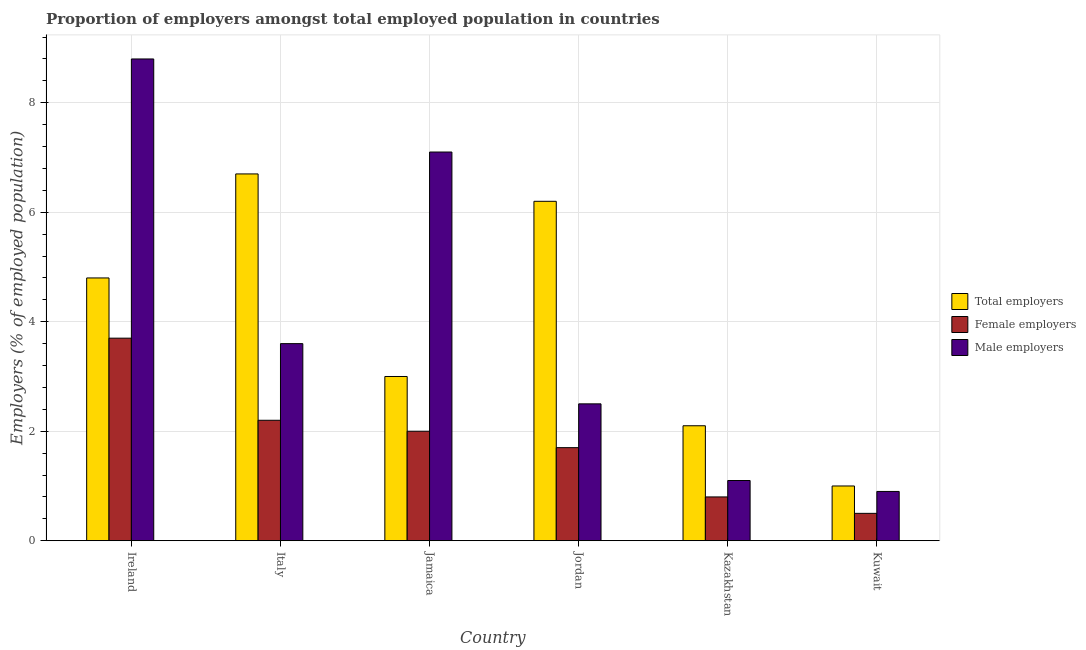Are the number of bars per tick equal to the number of legend labels?
Provide a short and direct response. Yes. What is the label of the 6th group of bars from the left?
Your answer should be very brief. Kuwait. In how many cases, is the number of bars for a given country not equal to the number of legend labels?
Ensure brevity in your answer.  0. What is the percentage of male employers in Kazakhstan?
Your response must be concise. 1.1. Across all countries, what is the maximum percentage of male employers?
Your answer should be compact. 8.8. Across all countries, what is the minimum percentage of male employers?
Provide a succinct answer. 0.9. In which country was the percentage of female employers minimum?
Offer a very short reply. Kuwait. What is the total percentage of male employers in the graph?
Ensure brevity in your answer.  24. What is the difference between the percentage of male employers in Ireland and that in Kazakhstan?
Give a very brief answer. 7.7. What is the difference between the percentage of male employers in Kazakhstan and the percentage of female employers in Jamaica?
Offer a very short reply. -0.9. What is the average percentage of male employers per country?
Offer a terse response. 4. What is the difference between the percentage of male employers and percentage of total employers in Ireland?
Offer a terse response. 4. In how many countries, is the percentage of female employers greater than 6.8 %?
Keep it short and to the point. 0. What is the ratio of the percentage of female employers in Jordan to that in Kuwait?
Provide a short and direct response. 3.4. What is the difference between the highest and the second highest percentage of male employers?
Provide a succinct answer. 1.7. What is the difference between the highest and the lowest percentage of male employers?
Your answer should be very brief. 7.9. What does the 3rd bar from the left in Kuwait represents?
Provide a short and direct response. Male employers. What does the 3rd bar from the right in Kazakhstan represents?
Offer a terse response. Total employers. Is it the case that in every country, the sum of the percentage of total employers and percentage of female employers is greater than the percentage of male employers?
Provide a succinct answer. No. Are all the bars in the graph horizontal?
Your answer should be compact. No. How many countries are there in the graph?
Offer a very short reply. 6. What is the difference between two consecutive major ticks on the Y-axis?
Keep it short and to the point. 2. How many legend labels are there?
Offer a terse response. 3. What is the title of the graph?
Offer a very short reply. Proportion of employers amongst total employed population in countries. Does "Profit Tax" appear as one of the legend labels in the graph?
Provide a succinct answer. No. What is the label or title of the Y-axis?
Provide a short and direct response. Employers (% of employed population). What is the Employers (% of employed population) in Total employers in Ireland?
Your answer should be compact. 4.8. What is the Employers (% of employed population) of Female employers in Ireland?
Ensure brevity in your answer.  3.7. What is the Employers (% of employed population) in Male employers in Ireland?
Provide a short and direct response. 8.8. What is the Employers (% of employed population) in Total employers in Italy?
Offer a very short reply. 6.7. What is the Employers (% of employed population) in Female employers in Italy?
Provide a short and direct response. 2.2. What is the Employers (% of employed population) in Male employers in Italy?
Your response must be concise. 3.6. What is the Employers (% of employed population) of Total employers in Jamaica?
Ensure brevity in your answer.  3. What is the Employers (% of employed population) of Female employers in Jamaica?
Provide a succinct answer. 2. What is the Employers (% of employed population) in Male employers in Jamaica?
Your answer should be very brief. 7.1. What is the Employers (% of employed population) of Total employers in Jordan?
Your answer should be very brief. 6.2. What is the Employers (% of employed population) of Female employers in Jordan?
Make the answer very short. 1.7. What is the Employers (% of employed population) of Total employers in Kazakhstan?
Your response must be concise. 2.1. What is the Employers (% of employed population) of Female employers in Kazakhstan?
Your answer should be very brief. 0.8. What is the Employers (% of employed population) in Male employers in Kazakhstan?
Offer a terse response. 1.1. What is the Employers (% of employed population) of Total employers in Kuwait?
Give a very brief answer. 1. What is the Employers (% of employed population) in Female employers in Kuwait?
Offer a very short reply. 0.5. What is the Employers (% of employed population) of Male employers in Kuwait?
Keep it short and to the point. 0.9. Across all countries, what is the maximum Employers (% of employed population) of Total employers?
Keep it short and to the point. 6.7. Across all countries, what is the maximum Employers (% of employed population) of Female employers?
Make the answer very short. 3.7. Across all countries, what is the maximum Employers (% of employed population) of Male employers?
Give a very brief answer. 8.8. Across all countries, what is the minimum Employers (% of employed population) of Female employers?
Make the answer very short. 0.5. Across all countries, what is the minimum Employers (% of employed population) of Male employers?
Keep it short and to the point. 0.9. What is the total Employers (% of employed population) of Total employers in the graph?
Your answer should be compact. 23.8. What is the total Employers (% of employed population) of Male employers in the graph?
Keep it short and to the point. 24. What is the difference between the Employers (% of employed population) in Male employers in Ireland and that in Italy?
Offer a very short reply. 5.2. What is the difference between the Employers (% of employed population) of Total employers in Ireland and that in Jamaica?
Keep it short and to the point. 1.8. What is the difference between the Employers (% of employed population) of Male employers in Ireland and that in Jordan?
Ensure brevity in your answer.  6.3. What is the difference between the Employers (% of employed population) of Total employers in Ireland and that in Kazakhstan?
Provide a succinct answer. 2.7. What is the difference between the Employers (% of employed population) in Female employers in Ireland and that in Kazakhstan?
Give a very brief answer. 2.9. What is the difference between the Employers (% of employed population) in Total employers in Ireland and that in Kuwait?
Keep it short and to the point. 3.8. What is the difference between the Employers (% of employed population) of Total employers in Italy and that in Jamaica?
Ensure brevity in your answer.  3.7. What is the difference between the Employers (% of employed population) in Male employers in Italy and that in Jamaica?
Offer a very short reply. -3.5. What is the difference between the Employers (% of employed population) in Total employers in Italy and that in Jordan?
Your answer should be very brief. 0.5. What is the difference between the Employers (% of employed population) in Male employers in Italy and that in Jordan?
Your answer should be compact. 1.1. What is the difference between the Employers (% of employed population) of Total employers in Italy and that in Kazakhstan?
Make the answer very short. 4.6. What is the difference between the Employers (% of employed population) of Female employers in Italy and that in Kazakhstan?
Offer a terse response. 1.4. What is the difference between the Employers (% of employed population) of Female employers in Italy and that in Kuwait?
Offer a very short reply. 1.7. What is the difference between the Employers (% of employed population) in Total employers in Jamaica and that in Kazakhstan?
Give a very brief answer. 0.9. What is the difference between the Employers (% of employed population) in Female employers in Jamaica and that in Kazakhstan?
Ensure brevity in your answer.  1.2. What is the difference between the Employers (% of employed population) in Total employers in Jamaica and that in Kuwait?
Give a very brief answer. 2. What is the difference between the Employers (% of employed population) of Female employers in Jamaica and that in Kuwait?
Provide a short and direct response. 1.5. What is the difference between the Employers (% of employed population) in Male employers in Jamaica and that in Kuwait?
Provide a succinct answer. 6.2. What is the difference between the Employers (% of employed population) of Total employers in Jordan and that in Kazakhstan?
Make the answer very short. 4.1. What is the difference between the Employers (% of employed population) of Female employers in Jordan and that in Kazakhstan?
Offer a terse response. 0.9. What is the difference between the Employers (% of employed population) of Male employers in Jordan and that in Kazakhstan?
Make the answer very short. 1.4. What is the difference between the Employers (% of employed population) of Total employers in Jordan and that in Kuwait?
Offer a terse response. 5.2. What is the difference between the Employers (% of employed population) in Total employers in Kazakhstan and that in Kuwait?
Ensure brevity in your answer.  1.1. What is the difference between the Employers (% of employed population) in Female employers in Kazakhstan and that in Kuwait?
Make the answer very short. 0.3. What is the difference between the Employers (% of employed population) of Male employers in Kazakhstan and that in Kuwait?
Offer a very short reply. 0.2. What is the difference between the Employers (% of employed population) in Total employers in Ireland and the Employers (% of employed population) in Female employers in Italy?
Your answer should be very brief. 2.6. What is the difference between the Employers (% of employed population) in Total employers in Ireland and the Employers (% of employed population) in Male employers in Jamaica?
Your answer should be compact. -2.3. What is the difference between the Employers (% of employed population) in Total employers in Ireland and the Employers (% of employed population) in Female employers in Kazakhstan?
Offer a terse response. 4. What is the difference between the Employers (% of employed population) of Total employers in Ireland and the Employers (% of employed population) of Male employers in Kazakhstan?
Provide a short and direct response. 3.7. What is the difference between the Employers (% of employed population) in Female employers in Ireland and the Employers (% of employed population) in Male employers in Kazakhstan?
Offer a terse response. 2.6. What is the difference between the Employers (% of employed population) in Total employers in Ireland and the Employers (% of employed population) in Female employers in Kuwait?
Your answer should be very brief. 4.3. What is the difference between the Employers (% of employed population) in Total employers in Ireland and the Employers (% of employed population) in Male employers in Kuwait?
Provide a succinct answer. 3.9. What is the difference between the Employers (% of employed population) of Female employers in Italy and the Employers (% of employed population) of Male employers in Jamaica?
Keep it short and to the point. -4.9. What is the difference between the Employers (% of employed population) of Total employers in Italy and the Employers (% of employed population) of Male employers in Jordan?
Offer a very short reply. 4.2. What is the difference between the Employers (% of employed population) of Female employers in Italy and the Employers (% of employed population) of Male employers in Kazakhstan?
Your response must be concise. 1.1. What is the difference between the Employers (% of employed population) in Total employers in Italy and the Employers (% of employed population) in Female employers in Kuwait?
Your answer should be compact. 6.2. What is the difference between the Employers (% of employed population) in Female employers in Italy and the Employers (% of employed population) in Male employers in Kuwait?
Offer a terse response. 1.3. What is the difference between the Employers (% of employed population) in Total employers in Jamaica and the Employers (% of employed population) in Female employers in Jordan?
Keep it short and to the point. 1.3. What is the difference between the Employers (% of employed population) of Total employers in Jamaica and the Employers (% of employed population) of Male employers in Jordan?
Ensure brevity in your answer.  0.5. What is the difference between the Employers (% of employed population) in Female employers in Jamaica and the Employers (% of employed population) in Male employers in Jordan?
Offer a terse response. -0.5. What is the difference between the Employers (% of employed population) of Total employers in Jamaica and the Employers (% of employed population) of Male employers in Kazakhstan?
Make the answer very short. 1.9. What is the difference between the Employers (% of employed population) in Total employers in Jamaica and the Employers (% of employed population) in Female employers in Kuwait?
Give a very brief answer. 2.5. What is the difference between the Employers (% of employed population) of Total employers in Jamaica and the Employers (% of employed population) of Male employers in Kuwait?
Provide a short and direct response. 2.1. What is the difference between the Employers (% of employed population) of Female employers in Jamaica and the Employers (% of employed population) of Male employers in Kuwait?
Make the answer very short. 1.1. What is the difference between the Employers (% of employed population) of Total employers in Jordan and the Employers (% of employed population) of Male employers in Kazakhstan?
Offer a very short reply. 5.1. What is the difference between the Employers (% of employed population) in Female employers in Jordan and the Employers (% of employed population) in Male employers in Kazakhstan?
Provide a short and direct response. 0.6. What is the difference between the Employers (% of employed population) of Total employers in Jordan and the Employers (% of employed population) of Female employers in Kuwait?
Make the answer very short. 5.7. What is the difference between the Employers (% of employed population) in Total employers in Jordan and the Employers (% of employed population) in Male employers in Kuwait?
Your answer should be very brief. 5.3. What is the difference between the Employers (% of employed population) in Female employers in Jordan and the Employers (% of employed population) in Male employers in Kuwait?
Provide a short and direct response. 0.8. What is the difference between the Employers (% of employed population) of Total employers in Kazakhstan and the Employers (% of employed population) of Female employers in Kuwait?
Your response must be concise. 1.6. What is the difference between the Employers (% of employed population) in Total employers in Kazakhstan and the Employers (% of employed population) in Male employers in Kuwait?
Give a very brief answer. 1.2. What is the difference between the Employers (% of employed population) of Female employers in Kazakhstan and the Employers (% of employed population) of Male employers in Kuwait?
Give a very brief answer. -0.1. What is the average Employers (% of employed population) of Total employers per country?
Your answer should be very brief. 3.97. What is the average Employers (% of employed population) in Female employers per country?
Give a very brief answer. 1.82. What is the difference between the Employers (% of employed population) of Total employers and Employers (% of employed population) of Male employers in Ireland?
Provide a succinct answer. -4. What is the difference between the Employers (% of employed population) in Female employers and Employers (% of employed population) in Male employers in Ireland?
Offer a very short reply. -5.1. What is the difference between the Employers (% of employed population) in Female employers and Employers (% of employed population) in Male employers in Italy?
Your answer should be compact. -1.4. What is the difference between the Employers (% of employed population) in Total employers and Employers (% of employed population) in Female employers in Jamaica?
Keep it short and to the point. 1. What is the difference between the Employers (% of employed population) of Female employers and Employers (% of employed population) of Male employers in Jamaica?
Provide a succinct answer. -5.1. What is the difference between the Employers (% of employed population) of Total employers and Employers (% of employed population) of Female employers in Kazakhstan?
Give a very brief answer. 1.3. What is the difference between the Employers (% of employed population) of Total employers and Employers (% of employed population) of Male employers in Kazakhstan?
Offer a terse response. 1. What is the ratio of the Employers (% of employed population) of Total employers in Ireland to that in Italy?
Your answer should be very brief. 0.72. What is the ratio of the Employers (% of employed population) in Female employers in Ireland to that in Italy?
Offer a very short reply. 1.68. What is the ratio of the Employers (% of employed population) in Male employers in Ireland to that in Italy?
Your answer should be very brief. 2.44. What is the ratio of the Employers (% of employed population) in Total employers in Ireland to that in Jamaica?
Offer a terse response. 1.6. What is the ratio of the Employers (% of employed population) in Female employers in Ireland to that in Jamaica?
Provide a succinct answer. 1.85. What is the ratio of the Employers (% of employed population) in Male employers in Ireland to that in Jamaica?
Your response must be concise. 1.24. What is the ratio of the Employers (% of employed population) in Total employers in Ireland to that in Jordan?
Provide a succinct answer. 0.77. What is the ratio of the Employers (% of employed population) of Female employers in Ireland to that in Jordan?
Ensure brevity in your answer.  2.18. What is the ratio of the Employers (% of employed population) in Male employers in Ireland to that in Jordan?
Your answer should be compact. 3.52. What is the ratio of the Employers (% of employed population) in Total employers in Ireland to that in Kazakhstan?
Give a very brief answer. 2.29. What is the ratio of the Employers (% of employed population) of Female employers in Ireland to that in Kazakhstan?
Make the answer very short. 4.62. What is the ratio of the Employers (% of employed population) of Male employers in Ireland to that in Kazakhstan?
Offer a terse response. 8. What is the ratio of the Employers (% of employed population) in Male employers in Ireland to that in Kuwait?
Your response must be concise. 9.78. What is the ratio of the Employers (% of employed population) of Total employers in Italy to that in Jamaica?
Provide a succinct answer. 2.23. What is the ratio of the Employers (% of employed population) of Female employers in Italy to that in Jamaica?
Your answer should be compact. 1.1. What is the ratio of the Employers (% of employed population) of Male employers in Italy to that in Jamaica?
Provide a short and direct response. 0.51. What is the ratio of the Employers (% of employed population) of Total employers in Italy to that in Jordan?
Offer a terse response. 1.08. What is the ratio of the Employers (% of employed population) of Female employers in Italy to that in Jordan?
Offer a very short reply. 1.29. What is the ratio of the Employers (% of employed population) in Male employers in Italy to that in Jordan?
Keep it short and to the point. 1.44. What is the ratio of the Employers (% of employed population) in Total employers in Italy to that in Kazakhstan?
Give a very brief answer. 3.19. What is the ratio of the Employers (% of employed population) of Female employers in Italy to that in Kazakhstan?
Offer a very short reply. 2.75. What is the ratio of the Employers (% of employed population) of Male employers in Italy to that in Kazakhstan?
Provide a short and direct response. 3.27. What is the ratio of the Employers (% of employed population) of Total employers in Jamaica to that in Jordan?
Make the answer very short. 0.48. What is the ratio of the Employers (% of employed population) in Female employers in Jamaica to that in Jordan?
Give a very brief answer. 1.18. What is the ratio of the Employers (% of employed population) in Male employers in Jamaica to that in Jordan?
Offer a very short reply. 2.84. What is the ratio of the Employers (% of employed population) in Total employers in Jamaica to that in Kazakhstan?
Your answer should be compact. 1.43. What is the ratio of the Employers (% of employed population) of Female employers in Jamaica to that in Kazakhstan?
Your answer should be compact. 2.5. What is the ratio of the Employers (% of employed population) of Male employers in Jamaica to that in Kazakhstan?
Offer a terse response. 6.45. What is the ratio of the Employers (% of employed population) in Male employers in Jamaica to that in Kuwait?
Your answer should be very brief. 7.89. What is the ratio of the Employers (% of employed population) in Total employers in Jordan to that in Kazakhstan?
Make the answer very short. 2.95. What is the ratio of the Employers (% of employed population) in Female employers in Jordan to that in Kazakhstan?
Your response must be concise. 2.12. What is the ratio of the Employers (% of employed population) of Male employers in Jordan to that in Kazakhstan?
Provide a succinct answer. 2.27. What is the ratio of the Employers (% of employed population) in Female employers in Jordan to that in Kuwait?
Provide a short and direct response. 3.4. What is the ratio of the Employers (% of employed population) of Male employers in Jordan to that in Kuwait?
Your answer should be very brief. 2.78. What is the ratio of the Employers (% of employed population) in Total employers in Kazakhstan to that in Kuwait?
Ensure brevity in your answer.  2.1. What is the ratio of the Employers (% of employed population) in Female employers in Kazakhstan to that in Kuwait?
Give a very brief answer. 1.6. What is the ratio of the Employers (% of employed population) of Male employers in Kazakhstan to that in Kuwait?
Your answer should be very brief. 1.22. What is the difference between the highest and the second highest Employers (% of employed population) in Total employers?
Ensure brevity in your answer.  0.5. What is the difference between the highest and the second highest Employers (% of employed population) of Female employers?
Give a very brief answer. 1.5. What is the difference between the highest and the second highest Employers (% of employed population) in Male employers?
Your response must be concise. 1.7. 